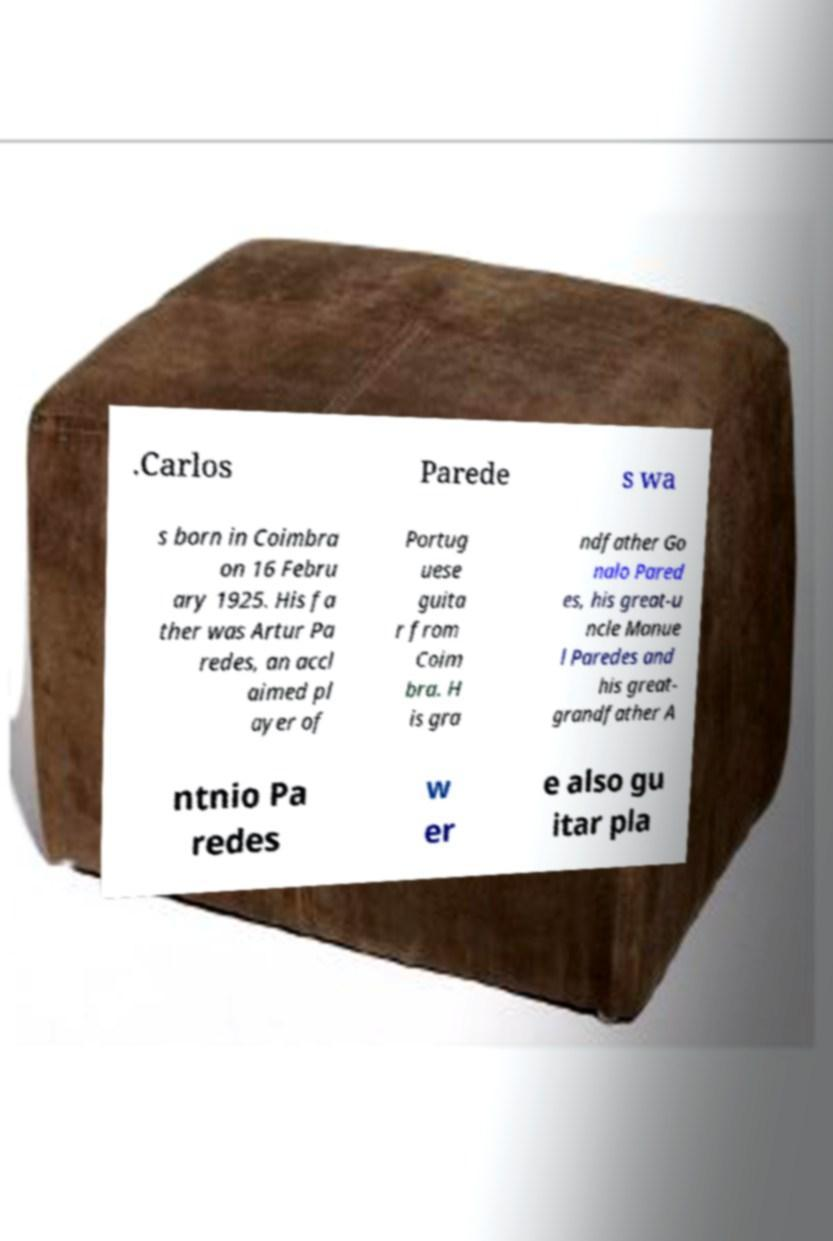There's text embedded in this image that I need extracted. Can you transcribe it verbatim? .Carlos Parede s wa s born in Coimbra on 16 Febru ary 1925. His fa ther was Artur Pa redes, an accl aimed pl ayer of Portug uese guita r from Coim bra. H is gra ndfather Go nalo Pared es, his great-u ncle Manue l Paredes and his great- grandfather A ntnio Pa redes w er e also gu itar pla 